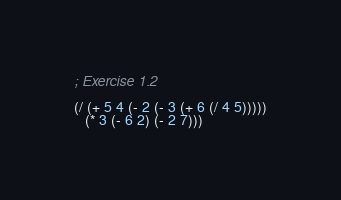Convert code to text. <code><loc_0><loc_0><loc_500><loc_500><_Scheme_>; Exercise 1.2

(/ (+ 5 4 (- 2 (- 3 (+ 6 (/ 4 5)))))
   (* 3 (- 6 2) (- 2 7)))
</code> 